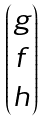Convert formula to latex. <formula><loc_0><loc_0><loc_500><loc_500>\begin{pmatrix} g \\ f \\ h \end{pmatrix}</formula> 